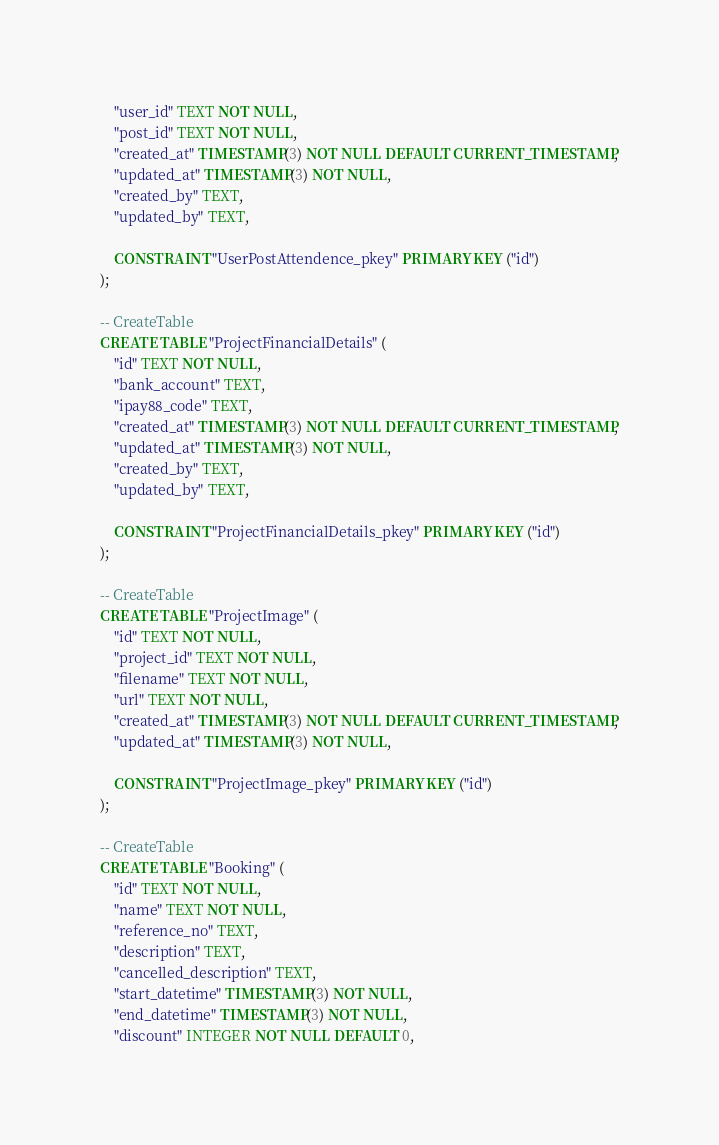<code> <loc_0><loc_0><loc_500><loc_500><_SQL_>    "user_id" TEXT NOT NULL,
    "post_id" TEXT NOT NULL,
    "created_at" TIMESTAMP(3) NOT NULL DEFAULT CURRENT_TIMESTAMP,
    "updated_at" TIMESTAMP(3) NOT NULL,
    "created_by" TEXT,
    "updated_by" TEXT,

    CONSTRAINT "UserPostAttendence_pkey" PRIMARY KEY ("id")
);

-- CreateTable
CREATE TABLE "ProjectFinancialDetails" (
    "id" TEXT NOT NULL,
    "bank_account" TEXT,
    "ipay88_code" TEXT,
    "created_at" TIMESTAMP(3) NOT NULL DEFAULT CURRENT_TIMESTAMP,
    "updated_at" TIMESTAMP(3) NOT NULL,
    "created_by" TEXT,
    "updated_by" TEXT,

    CONSTRAINT "ProjectFinancialDetails_pkey" PRIMARY KEY ("id")
);

-- CreateTable
CREATE TABLE "ProjectImage" (
    "id" TEXT NOT NULL,
    "project_id" TEXT NOT NULL,
    "filename" TEXT NOT NULL,
    "url" TEXT NOT NULL,
    "created_at" TIMESTAMP(3) NOT NULL DEFAULT CURRENT_TIMESTAMP,
    "updated_at" TIMESTAMP(3) NOT NULL,

    CONSTRAINT "ProjectImage_pkey" PRIMARY KEY ("id")
);

-- CreateTable
CREATE TABLE "Booking" (
    "id" TEXT NOT NULL,
    "name" TEXT NOT NULL,
    "reference_no" TEXT,
    "description" TEXT,
    "cancelled_description" TEXT,
    "start_datetime" TIMESTAMP(3) NOT NULL,
    "end_datetime" TIMESTAMP(3) NOT NULL,
    "discount" INTEGER NOT NULL DEFAULT 0,</code> 